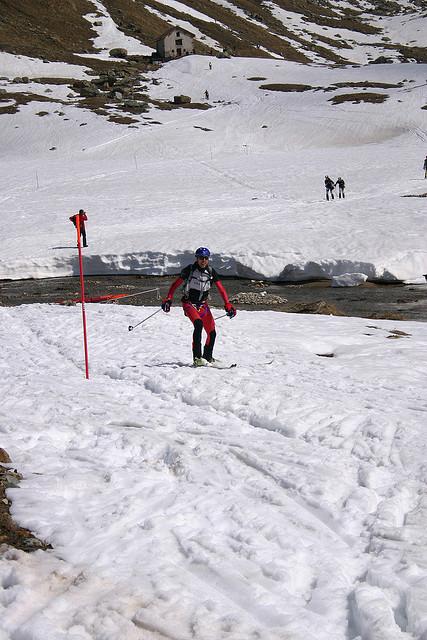How many people are out there?
Write a very short answer. 3. How far did the man ski today?
Give a very brief answer. 2 miles. Is the man on flat ground or a mountain?
Write a very short answer. Flat ground. 